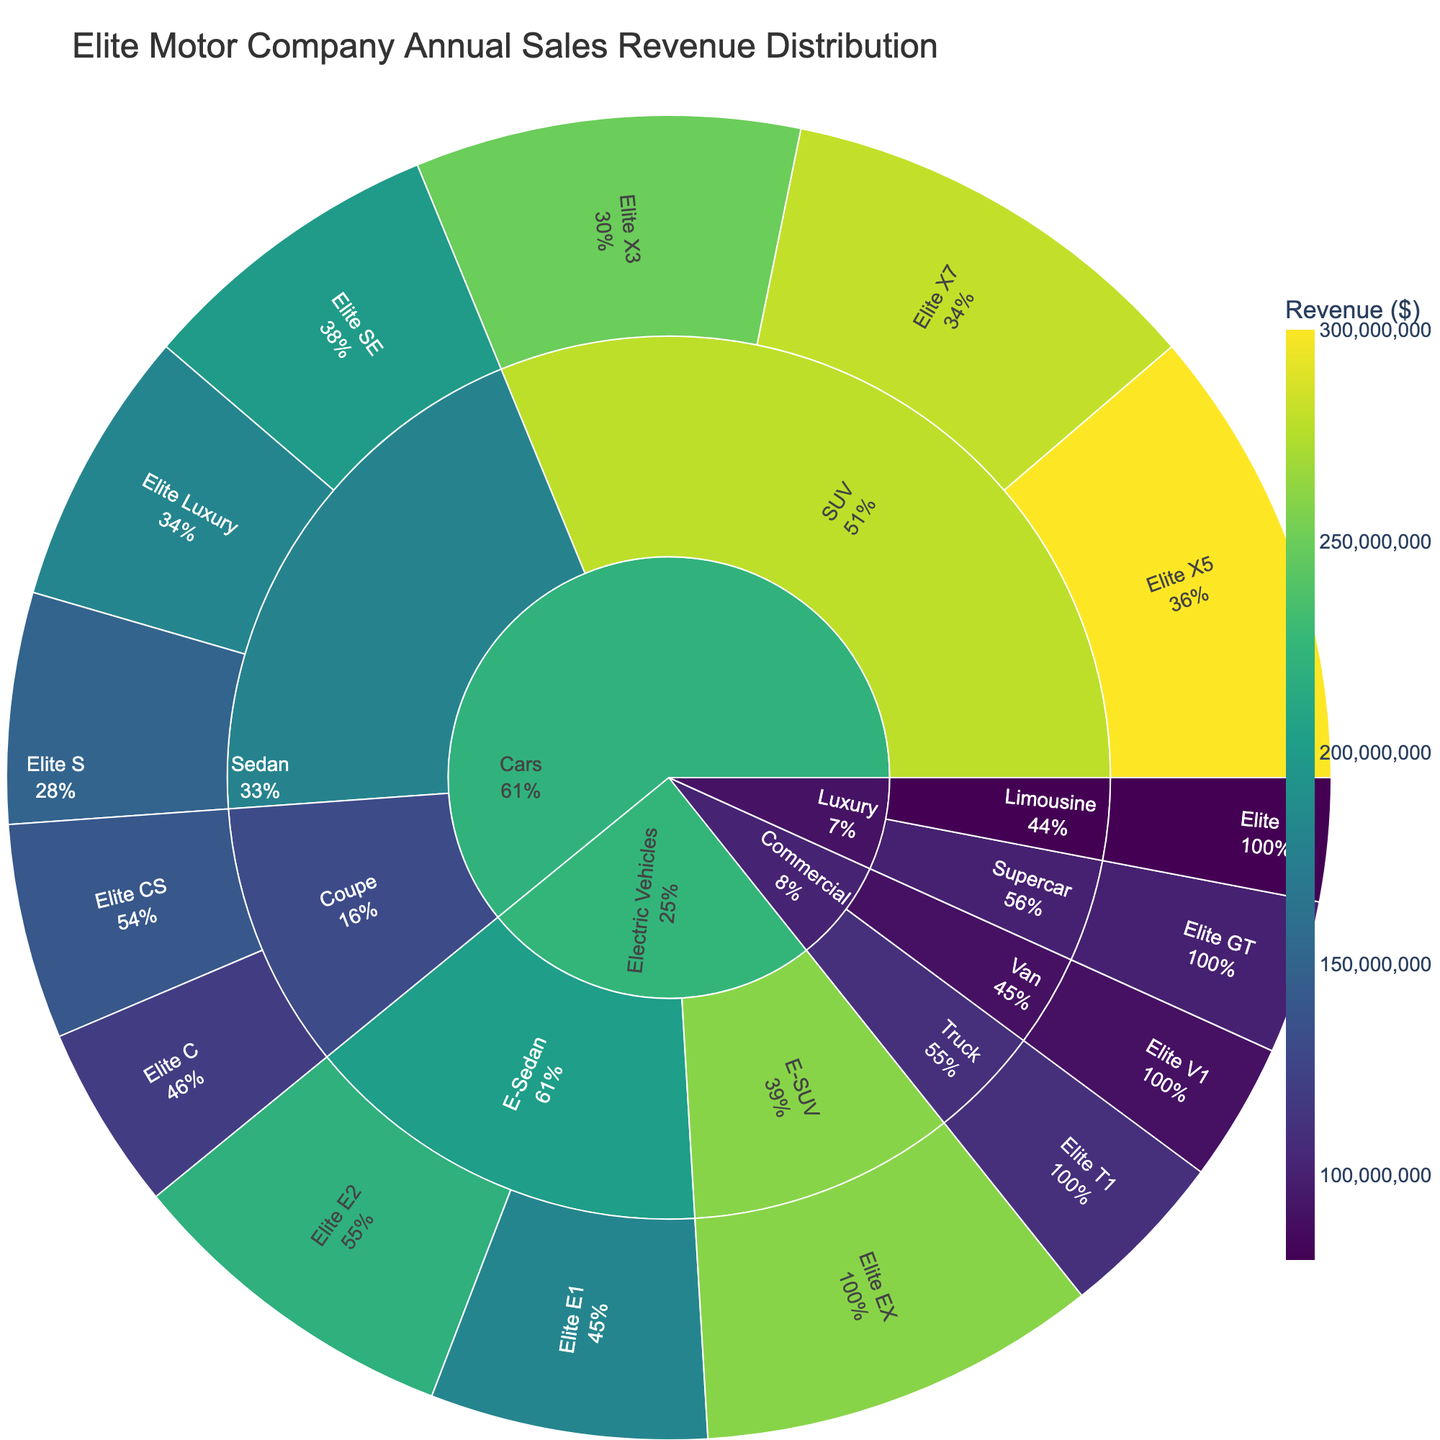What's the total revenue from Sedan models in the Cars category? The Sedan models are "Elite S," "Elite SE," and "Elite Luxury." Summing up their revenues: 150,000,000 + 200,000,000 + 180,000,000 = 530,000,000.
Answer: 530,000,000 Which trim level contributes the most revenue within the Electric Vehicles category? The Electric Vehicles category has three trim levels: "Elite E1," "Elite E2," and "Elite EX." Their revenues are 180,000,000, 220,000,000, and 260,000,000 respectively. The highest revenue is from "Elite EX."
Answer: Elite EX What's the percentage revenue contribution of the Elite X5 trim relative to the entire Cars category? The entire Cars category includes revenues from "Sedan," "Coupe," and "SUV." Sum up their revenues: (150,000,000 + 200,000,000 + 180,000,000) + (120,000,000 + 140,000,000) + (250,000,000 + 300,000,000 + 280,000,000) = 1,620,000,000. The revenue from "Elite X5" is 300,000,000. So the percentage is (300,000,000 / 1,620,000,000) = 0.185 or 18.5%.
Answer: 18.5% Which category has the least total revenue, and what is it? Calculate total revenues for each category: "Cars" has 1,620,000,000, "Electric Vehicles" has 660,000,000, "Luxury" has 180,000,000, and "Commercial" has 200,000,000. The "Luxury" category has the least total revenue of 180,000,000.
Answer: Luxury, 180,000,000 What is the revenue difference between the Elite X7 and Elite E2 trims? The revenues are 280,000,000 for "Elite X7" and 220,000,000 for "Elite E2." The difference is 280,000,000 - 220,000,000 = 60,000,000.
Answer: 60,000,000 What is the combined revenue from the Elite C and Elite CS trims in the Coupe model? "Elite C" has a revenue of 120,000,000, and "Elite CS" has 140,000,000. Their combined revenue is 120,000,000 + 140,000,000 = 260,000,000.
Answer: 260,000,000 In the Commercial category, which model generates more revenue, Van or Truck? The "Van" model has a revenue of 90,000,000 and the "Truck" model has 110,000,000. The "Truck" generates more revenue.
Answer: Truck How many trim levels exist under the Cars category? The Cars category includes Sedan, Coupe, and SUV models with the following trim levels: "Elite S," "Elite SE," "Elite Luxury," "Elite C," "Elite CS," "Elite X3," "Elite X5," and "Elite X7." There are a total of 8 trim levels.
Answer: 8 